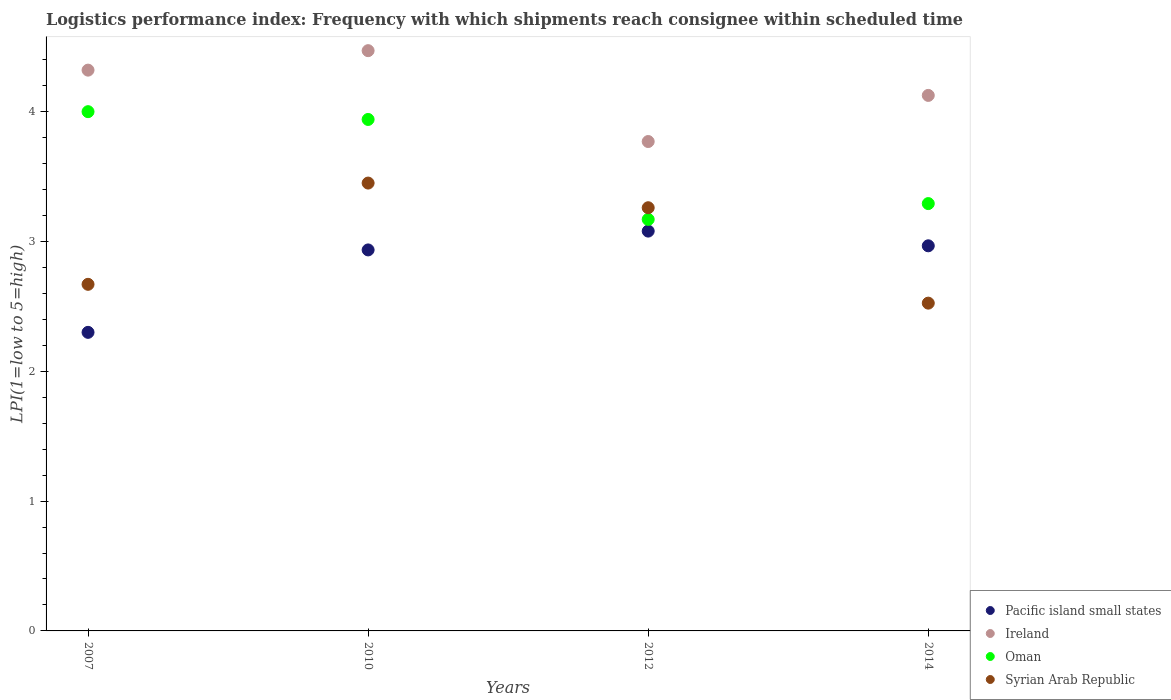How many different coloured dotlines are there?
Give a very brief answer. 4. What is the logistics performance index in Syrian Arab Republic in 2010?
Keep it short and to the point. 3.45. Across all years, what is the maximum logistics performance index in Oman?
Give a very brief answer. 4. In which year was the logistics performance index in Pacific island small states maximum?
Offer a very short reply. 2012. In which year was the logistics performance index in Pacific island small states minimum?
Your answer should be very brief. 2007. What is the total logistics performance index in Syrian Arab Republic in the graph?
Offer a terse response. 11.91. What is the difference between the logistics performance index in Oman in 2007 and that in 2014?
Make the answer very short. 0.71. What is the difference between the logistics performance index in Syrian Arab Republic in 2012 and the logistics performance index in Oman in 2010?
Your response must be concise. -0.68. What is the average logistics performance index in Syrian Arab Republic per year?
Your answer should be compact. 2.98. In the year 2010, what is the difference between the logistics performance index in Pacific island small states and logistics performance index in Oman?
Your response must be concise. -1. In how many years, is the logistics performance index in Pacific island small states greater than 1.4?
Give a very brief answer. 4. What is the ratio of the logistics performance index in Ireland in 2012 to that in 2014?
Make the answer very short. 0.91. Is the logistics performance index in Syrian Arab Republic in 2010 less than that in 2012?
Give a very brief answer. No. What is the difference between the highest and the second highest logistics performance index in Syrian Arab Republic?
Your response must be concise. 0.19. What is the difference between the highest and the lowest logistics performance index in Oman?
Provide a short and direct response. 0.83. Is it the case that in every year, the sum of the logistics performance index in Pacific island small states and logistics performance index in Syrian Arab Republic  is greater than the sum of logistics performance index in Ireland and logistics performance index in Oman?
Offer a very short reply. No. Is it the case that in every year, the sum of the logistics performance index in Syrian Arab Republic and logistics performance index in Oman  is greater than the logistics performance index in Pacific island small states?
Offer a very short reply. Yes. Does the logistics performance index in Ireland monotonically increase over the years?
Keep it short and to the point. No. Is the logistics performance index in Syrian Arab Republic strictly less than the logistics performance index in Oman over the years?
Ensure brevity in your answer.  No. How many dotlines are there?
Your answer should be compact. 4. Are the values on the major ticks of Y-axis written in scientific E-notation?
Your answer should be very brief. No. Does the graph contain grids?
Provide a succinct answer. No. Where does the legend appear in the graph?
Offer a terse response. Bottom right. What is the title of the graph?
Provide a short and direct response. Logistics performance index: Frequency with which shipments reach consignee within scheduled time. Does "Central African Republic" appear as one of the legend labels in the graph?
Keep it short and to the point. No. What is the label or title of the Y-axis?
Your answer should be compact. LPI(1=low to 5=high). What is the LPI(1=low to 5=high) of Pacific island small states in 2007?
Keep it short and to the point. 2.3. What is the LPI(1=low to 5=high) of Ireland in 2007?
Offer a terse response. 4.32. What is the LPI(1=low to 5=high) in Oman in 2007?
Your answer should be compact. 4. What is the LPI(1=low to 5=high) of Syrian Arab Republic in 2007?
Provide a short and direct response. 2.67. What is the LPI(1=low to 5=high) of Pacific island small states in 2010?
Keep it short and to the point. 2.94. What is the LPI(1=low to 5=high) of Ireland in 2010?
Provide a succinct answer. 4.47. What is the LPI(1=low to 5=high) of Oman in 2010?
Ensure brevity in your answer.  3.94. What is the LPI(1=low to 5=high) in Syrian Arab Republic in 2010?
Your answer should be very brief. 3.45. What is the LPI(1=low to 5=high) in Pacific island small states in 2012?
Provide a short and direct response. 3.08. What is the LPI(1=low to 5=high) of Ireland in 2012?
Offer a terse response. 3.77. What is the LPI(1=low to 5=high) of Oman in 2012?
Offer a very short reply. 3.17. What is the LPI(1=low to 5=high) in Syrian Arab Republic in 2012?
Your answer should be very brief. 3.26. What is the LPI(1=low to 5=high) of Pacific island small states in 2014?
Your answer should be compact. 2.97. What is the LPI(1=low to 5=high) of Ireland in 2014?
Make the answer very short. 4.13. What is the LPI(1=low to 5=high) in Oman in 2014?
Your answer should be very brief. 3.29. What is the LPI(1=low to 5=high) in Syrian Arab Republic in 2014?
Provide a succinct answer. 2.53. Across all years, what is the maximum LPI(1=low to 5=high) of Pacific island small states?
Make the answer very short. 3.08. Across all years, what is the maximum LPI(1=low to 5=high) in Ireland?
Provide a short and direct response. 4.47. Across all years, what is the maximum LPI(1=low to 5=high) in Syrian Arab Republic?
Offer a very short reply. 3.45. Across all years, what is the minimum LPI(1=low to 5=high) in Ireland?
Make the answer very short. 3.77. Across all years, what is the minimum LPI(1=low to 5=high) of Oman?
Provide a succinct answer. 3.17. Across all years, what is the minimum LPI(1=low to 5=high) of Syrian Arab Republic?
Your answer should be very brief. 2.53. What is the total LPI(1=low to 5=high) of Pacific island small states in the graph?
Provide a short and direct response. 11.28. What is the total LPI(1=low to 5=high) in Ireland in the graph?
Provide a succinct answer. 16.69. What is the total LPI(1=low to 5=high) in Oman in the graph?
Give a very brief answer. 14.4. What is the total LPI(1=low to 5=high) of Syrian Arab Republic in the graph?
Offer a very short reply. 11.9. What is the difference between the LPI(1=low to 5=high) of Pacific island small states in 2007 and that in 2010?
Keep it short and to the point. -0.64. What is the difference between the LPI(1=low to 5=high) of Oman in 2007 and that in 2010?
Ensure brevity in your answer.  0.06. What is the difference between the LPI(1=low to 5=high) in Syrian Arab Republic in 2007 and that in 2010?
Offer a terse response. -0.78. What is the difference between the LPI(1=low to 5=high) of Pacific island small states in 2007 and that in 2012?
Give a very brief answer. -0.78. What is the difference between the LPI(1=low to 5=high) of Ireland in 2007 and that in 2012?
Offer a terse response. 0.55. What is the difference between the LPI(1=low to 5=high) of Oman in 2007 and that in 2012?
Give a very brief answer. 0.83. What is the difference between the LPI(1=low to 5=high) of Syrian Arab Republic in 2007 and that in 2012?
Your answer should be compact. -0.59. What is the difference between the LPI(1=low to 5=high) in Ireland in 2007 and that in 2014?
Provide a succinct answer. 0.19. What is the difference between the LPI(1=low to 5=high) of Oman in 2007 and that in 2014?
Provide a succinct answer. 0.71. What is the difference between the LPI(1=low to 5=high) of Syrian Arab Republic in 2007 and that in 2014?
Ensure brevity in your answer.  0.14. What is the difference between the LPI(1=low to 5=high) in Pacific island small states in 2010 and that in 2012?
Offer a terse response. -0.14. What is the difference between the LPI(1=low to 5=high) in Ireland in 2010 and that in 2012?
Ensure brevity in your answer.  0.7. What is the difference between the LPI(1=low to 5=high) in Oman in 2010 and that in 2012?
Give a very brief answer. 0.77. What is the difference between the LPI(1=low to 5=high) in Syrian Arab Republic in 2010 and that in 2012?
Provide a short and direct response. 0.19. What is the difference between the LPI(1=low to 5=high) in Pacific island small states in 2010 and that in 2014?
Make the answer very short. -0.03. What is the difference between the LPI(1=low to 5=high) of Ireland in 2010 and that in 2014?
Ensure brevity in your answer.  0.34. What is the difference between the LPI(1=low to 5=high) in Oman in 2010 and that in 2014?
Provide a succinct answer. 0.65. What is the difference between the LPI(1=low to 5=high) of Syrian Arab Republic in 2010 and that in 2014?
Give a very brief answer. 0.93. What is the difference between the LPI(1=low to 5=high) of Pacific island small states in 2012 and that in 2014?
Your response must be concise. 0.11. What is the difference between the LPI(1=low to 5=high) of Ireland in 2012 and that in 2014?
Offer a terse response. -0.36. What is the difference between the LPI(1=low to 5=high) of Oman in 2012 and that in 2014?
Offer a terse response. -0.12. What is the difference between the LPI(1=low to 5=high) in Syrian Arab Republic in 2012 and that in 2014?
Keep it short and to the point. 0.73. What is the difference between the LPI(1=low to 5=high) in Pacific island small states in 2007 and the LPI(1=low to 5=high) in Ireland in 2010?
Your response must be concise. -2.17. What is the difference between the LPI(1=low to 5=high) in Pacific island small states in 2007 and the LPI(1=low to 5=high) in Oman in 2010?
Make the answer very short. -1.64. What is the difference between the LPI(1=low to 5=high) in Pacific island small states in 2007 and the LPI(1=low to 5=high) in Syrian Arab Republic in 2010?
Your response must be concise. -1.15. What is the difference between the LPI(1=low to 5=high) in Ireland in 2007 and the LPI(1=low to 5=high) in Oman in 2010?
Your response must be concise. 0.38. What is the difference between the LPI(1=low to 5=high) in Ireland in 2007 and the LPI(1=low to 5=high) in Syrian Arab Republic in 2010?
Ensure brevity in your answer.  0.87. What is the difference between the LPI(1=low to 5=high) of Oman in 2007 and the LPI(1=low to 5=high) of Syrian Arab Republic in 2010?
Your answer should be very brief. 0.55. What is the difference between the LPI(1=low to 5=high) of Pacific island small states in 2007 and the LPI(1=low to 5=high) of Ireland in 2012?
Offer a terse response. -1.47. What is the difference between the LPI(1=low to 5=high) of Pacific island small states in 2007 and the LPI(1=low to 5=high) of Oman in 2012?
Provide a succinct answer. -0.87. What is the difference between the LPI(1=low to 5=high) of Pacific island small states in 2007 and the LPI(1=low to 5=high) of Syrian Arab Republic in 2012?
Provide a succinct answer. -0.96. What is the difference between the LPI(1=low to 5=high) in Ireland in 2007 and the LPI(1=low to 5=high) in Oman in 2012?
Make the answer very short. 1.15. What is the difference between the LPI(1=low to 5=high) in Ireland in 2007 and the LPI(1=low to 5=high) in Syrian Arab Republic in 2012?
Your response must be concise. 1.06. What is the difference between the LPI(1=low to 5=high) of Oman in 2007 and the LPI(1=low to 5=high) of Syrian Arab Republic in 2012?
Your response must be concise. 0.74. What is the difference between the LPI(1=low to 5=high) in Pacific island small states in 2007 and the LPI(1=low to 5=high) in Ireland in 2014?
Provide a short and direct response. -1.83. What is the difference between the LPI(1=low to 5=high) in Pacific island small states in 2007 and the LPI(1=low to 5=high) in Oman in 2014?
Your answer should be very brief. -0.99. What is the difference between the LPI(1=low to 5=high) in Pacific island small states in 2007 and the LPI(1=low to 5=high) in Syrian Arab Republic in 2014?
Keep it short and to the point. -0.23. What is the difference between the LPI(1=low to 5=high) in Ireland in 2007 and the LPI(1=low to 5=high) in Oman in 2014?
Offer a very short reply. 1.03. What is the difference between the LPI(1=low to 5=high) of Ireland in 2007 and the LPI(1=low to 5=high) of Syrian Arab Republic in 2014?
Make the answer very short. 1.79. What is the difference between the LPI(1=low to 5=high) of Oman in 2007 and the LPI(1=low to 5=high) of Syrian Arab Republic in 2014?
Give a very brief answer. 1.48. What is the difference between the LPI(1=low to 5=high) in Pacific island small states in 2010 and the LPI(1=low to 5=high) in Ireland in 2012?
Make the answer very short. -0.83. What is the difference between the LPI(1=low to 5=high) in Pacific island small states in 2010 and the LPI(1=low to 5=high) in Oman in 2012?
Your response must be concise. -0.23. What is the difference between the LPI(1=low to 5=high) in Pacific island small states in 2010 and the LPI(1=low to 5=high) in Syrian Arab Republic in 2012?
Provide a short and direct response. -0.33. What is the difference between the LPI(1=low to 5=high) in Ireland in 2010 and the LPI(1=low to 5=high) in Oman in 2012?
Offer a very short reply. 1.3. What is the difference between the LPI(1=low to 5=high) in Ireland in 2010 and the LPI(1=low to 5=high) in Syrian Arab Republic in 2012?
Your answer should be compact. 1.21. What is the difference between the LPI(1=low to 5=high) in Oman in 2010 and the LPI(1=low to 5=high) in Syrian Arab Republic in 2012?
Your answer should be very brief. 0.68. What is the difference between the LPI(1=low to 5=high) in Pacific island small states in 2010 and the LPI(1=low to 5=high) in Ireland in 2014?
Your answer should be compact. -1.19. What is the difference between the LPI(1=low to 5=high) of Pacific island small states in 2010 and the LPI(1=low to 5=high) of Oman in 2014?
Your answer should be very brief. -0.36. What is the difference between the LPI(1=low to 5=high) of Pacific island small states in 2010 and the LPI(1=low to 5=high) of Syrian Arab Republic in 2014?
Your answer should be very brief. 0.41. What is the difference between the LPI(1=low to 5=high) in Ireland in 2010 and the LPI(1=low to 5=high) in Oman in 2014?
Offer a terse response. 1.18. What is the difference between the LPI(1=low to 5=high) in Ireland in 2010 and the LPI(1=low to 5=high) in Syrian Arab Republic in 2014?
Your answer should be compact. 1.95. What is the difference between the LPI(1=low to 5=high) in Oman in 2010 and the LPI(1=low to 5=high) in Syrian Arab Republic in 2014?
Make the answer very short. 1.42. What is the difference between the LPI(1=low to 5=high) in Pacific island small states in 2012 and the LPI(1=low to 5=high) in Ireland in 2014?
Give a very brief answer. -1.05. What is the difference between the LPI(1=low to 5=high) of Pacific island small states in 2012 and the LPI(1=low to 5=high) of Oman in 2014?
Offer a terse response. -0.21. What is the difference between the LPI(1=low to 5=high) of Pacific island small states in 2012 and the LPI(1=low to 5=high) of Syrian Arab Republic in 2014?
Provide a succinct answer. 0.56. What is the difference between the LPI(1=low to 5=high) in Ireland in 2012 and the LPI(1=low to 5=high) in Oman in 2014?
Your answer should be very brief. 0.48. What is the difference between the LPI(1=low to 5=high) of Ireland in 2012 and the LPI(1=low to 5=high) of Syrian Arab Republic in 2014?
Your answer should be very brief. 1.25. What is the difference between the LPI(1=low to 5=high) of Oman in 2012 and the LPI(1=low to 5=high) of Syrian Arab Republic in 2014?
Your answer should be very brief. 0.65. What is the average LPI(1=low to 5=high) of Pacific island small states per year?
Keep it short and to the point. 2.82. What is the average LPI(1=low to 5=high) in Ireland per year?
Your answer should be very brief. 4.17. What is the average LPI(1=low to 5=high) in Oman per year?
Your answer should be compact. 3.6. What is the average LPI(1=low to 5=high) in Syrian Arab Republic per year?
Give a very brief answer. 2.98. In the year 2007, what is the difference between the LPI(1=low to 5=high) in Pacific island small states and LPI(1=low to 5=high) in Ireland?
Make the answer very short. -2.02. In the year 2007, what is the difference between the LPI(1=low to 5=high) of Pacific island small states and LPI(1=low to 5=high) of Oman?
Offer a terse response. -1.7. In the year 2007, what is the difference between the LPI(1=low to 5=high) in Pacific island small states and LPI(1=low to 5=high) in Syrian Arab Republic?
Your response must be concise. -0.37. In the year 2007, what is the difference between the LPI(1=low to 5=high) in Ireland and LPI(1=low to 5=high) in Oman?
Ensure brevity in your answer.  0.32. In the year 2007, what is the difference between the LPI(1=low to 5=high) of Ireland and LPI(1=low to 5=high) of Syrian Arab Republic?
Offer a very short reply. 1.65. In the year 2007, what is the difference between the LPI(1=low to 5=high) in Oman and LPI(1=low to 5=high) in Syrian Arab Republic?
Provide a short and direct response. 1.33. In the year 2010, what is the difference between the LPI(1=low to 5=high) in Pacific island small states and LPI(1=low to 5=high) in Ireland?
Your answer should be very brief. -1.53. In the year 2010, what is the difference between the LPI(1=low to 5=high) of Pacific island small states and LPI(1=low to 5=high) of Oman?
Offer a very short reply. -1. In the year 2010, what is the difference between the LPI(1=low to 5=high) in Pacific island small states and LPI(1=low to 5=high) in Syrian Arab Republic?
Provide a short and direct response. -0.52. In the year 2010, what is the difference between the LPI(1=low to 5=high) in Ireland and LPI(1=low to 5=high) in Oman?
Your answer should be compact. 0.53. In the year 2010, what is the difference between the LPI(1=low to 5=high) in Ireland and LPI(1=low to 5=high) in Syrian Arab Republic?
Your answer should be very brief. 1.02. In the year 2010, what is the difference between the LPI(1=low to 5=high) in Oman and LPI(1=low to 5=high) in Syrian Arab Republic?
Provide a succinct answer. 0.49. In the year 2012, what is the difference between the LPI(1=low to 5=high) in Pacific island small states and LPI(1=low to 5=high) in Ireland?
Your response must be concise. -0.69. In the year 2012, what is the difference between the LPI(1=low to 5=high) of Pacific island small states and LPI(1=low to 5=high) of Oman?
Your response must be concise. -0.09. In the year 2012, what is the difference between the LPI(1=low to 5=high) of Pacific island small states and LPI(1=low to 5=high) of Syrian Arab Republic?
Make the answer very short. -0.18. In the year 2012, what is the difference between the LPI(1=low to 5=high) of Ireland and LPI(1=low to 5=high) of Syrian Arab Republic?
Give a very brief answer. 0.51. In the year 2012, what is the difference between the LPI(1=low to 5=high) in Oman and LPI(1=low to 5=high) in Syrian Arab Republic?
Your answer should be very brief. -0.09. In the year 2014, what is the difference between the LPI(1=low to 5=high) in Pacific island small states and LPI(1=low to 5=high) in Ireland?
Your response must be concise. -1.16. In the year 2014, what is the difference between the LPI(1=low to 5=high) of Pacific island small states and LPI(1=low to 5=high) of Oman?
Provide a short and direct response. -0.33. In the year 2014, what is the difference between the LPI(1=low to 5=high) in Pacific island small states and LPI(1=low to 5=high) in Syrian Arab Republic?
Provide a short and direct response. 0.44. In the year 2014, what is the difference between the LPI(1=low to 5=high) in Ireland and LPI(1=low to 5=high) in Syrian Arab Republic?
Keep it short and to the point. 1.6. In the year 2014, what is the difference between the LPI(1=low to 5=high) of Oman and LPI(1=low to 5=high) of Syrian Arab Republic?
Provide a short and direct response. 0.77. What is the ratio of the LPI(1=low to 5=high) in Pacific island small states in 2007 to that in 2010?
Ensure brevity in your answer.  0.78. What is the ratio of the LPI(1=low to 5=high) in Ireland in 2007 to that in 2010?
Your answer should be very brief. 0.97. What is the ratio of the LPI(1=low to 5=high) of Oman in 2007 to that in 2010?
Provide a succinct answer. 1.02. What is the ratio of the LPI(1=low to 5=high) of Syrian Arab Republic in 2007 to that in 2010?
Your answer should be compact. 0.77. What is the ratio of the LPI(1=low to 5=high) of Pacific island small states in 2007 to that in 2012?
Your answer should be compact. 0.75. What is the ratio of the LPI(1=low to 5=high) in Ireland in 2007 to that in 2012?
Give a very brief answer. 1.15. What is the ratio of the LPI(1=low to 5=high) of Oman in 2007 to that in 2012?
Make the answer very short. 1.26. What is the ratio of the LPI(1=low to 5=high) of Syrian Arab Republic in 2007 to that in 2012?
Your answer should be very brief. 0.82. What is the ratio of the LPI(1=low to 5=high) of Pacific island small states in 2007 to that in 2014?
Provide a short and direct response. 0.78. What is the ratio of the LPI(1=low to 5=high) in Ireland in 2007 to that in 2014?
Give a very brief answer. 1.05. What is the ratio of the LPI(1=low to 5=high) of Oman in 2007 to that in 2014?
Make the answer very short. 1.22. What is the ratio of the LPI(1=low to 5=high) in Syrian Arab Republic in 2007 to that in 2014?
Provide a short and direct response. 1.06. What is the ratio of the LPI(1=low to 5=high) in Pacific island small states in 2010 to that in 2012?
Keep it short and to the point. 0.95. What is the ratio of the LPI(1=low to 5=high) of Ireland in 2010 to that in 2012?
Your response must be concise. 1.19. What is the ratio of the LPI(1=low to 5=high) in Oman in 2010 to that in 2012?
Provide a short and direct response. 1.24. What is the ratio of the LPI(1=low to 5=high) in Syrian Arab Republic in 2010 to that in 2012?
Give a very brief answer. 1.06. What is the ratio of the LPI(1=low to 5=high) in Pacific island small states in 2010 to that in 2014?
Your response must be concise. 0.99. What is the ratio of the LPI(1=low to 5=high) in Ireland in 2010 to that in 2014?
Your response must be concise. 1.08. What is the ratio of the LPI(1=low to 5=high) of Oman in 2010 to that in 2014?
Offer a very short reply. 1.2. What is the ratio of the LPI(1=low to 5=high) in Syrian Arab Republic in 2010 to that in 2014?
Provide a succinct answer. 1.37. What is the ratio of the LPI(1=low to 5=high) in Pacific island small states in 2012 to that in 2014?
Keep it short and to the point. 1.04. What is the ratio of the LPI(1=low to 5=high) in Ireland in 2012 to that in 2014?
Ensure brevity in your answer.  0.91. What is the ratio of the LPI(1=low to 5=high) in Oman in 2012 to that in 2014?
Offer a very short reply. 0.96. What is the ratio of the LPI(1=low to 5=high) of Syrian Arab Republic in 2012 to that in 2014?
Your response must be concise. 1.29. What is the difference between the highest and the second highest LPI(1=low to 5=high) in Pacific island small states?
Ensure brevity in your answer.  0.11. What is the difference between the highest and the second highest LPI(1=low to 5=high) in Syrian Arab Republic?
Provide a short and direct response. 0.19. What is the difference between the highest and the lowest LPI(1=low to 5=high) in Pacific island small states?
Ensure brevity in your answer.  0.78. What is the difference between the highest and the lowest LPI(1=low to 5=high) of Ireland?
Ensure brevity in your answer.  0.7. What is the difference between the highest and the lowest LPI(1=low to 5=high) of Oman?
Offer a very short reply. 0.83. What is the difference between the highest and the lowest LPI(1=low to 5=high) of Syrian Arab Republic?
Provide a short and direct response. 0.93. 